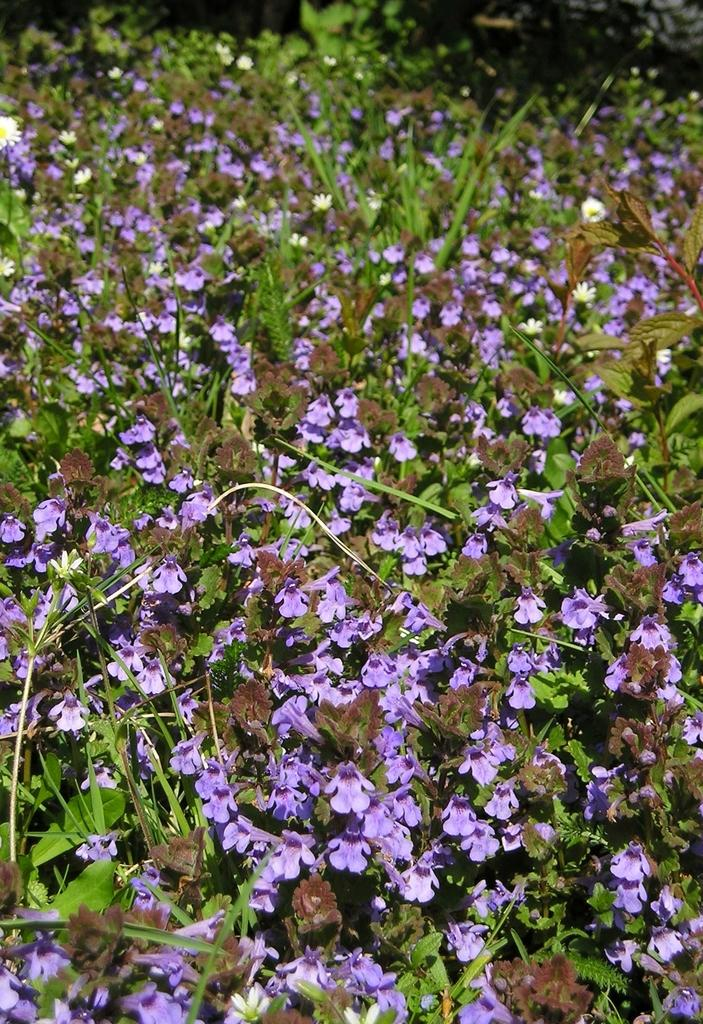What type of living organisms can be seen in the image? Plants can be seen in the image. What color are the flowers on the plants? The flowers on the plants are violet. Can you describe the background of the image? The backdrop of the image is blurred. How many yaks can be seen grazing in the image? There are no yaks present in the image; it features plants with violet flowers. What type of dirt is visible on the plants in the image? There is no dirt visible on the plants in the image; it only shows the plants and their flowers. 